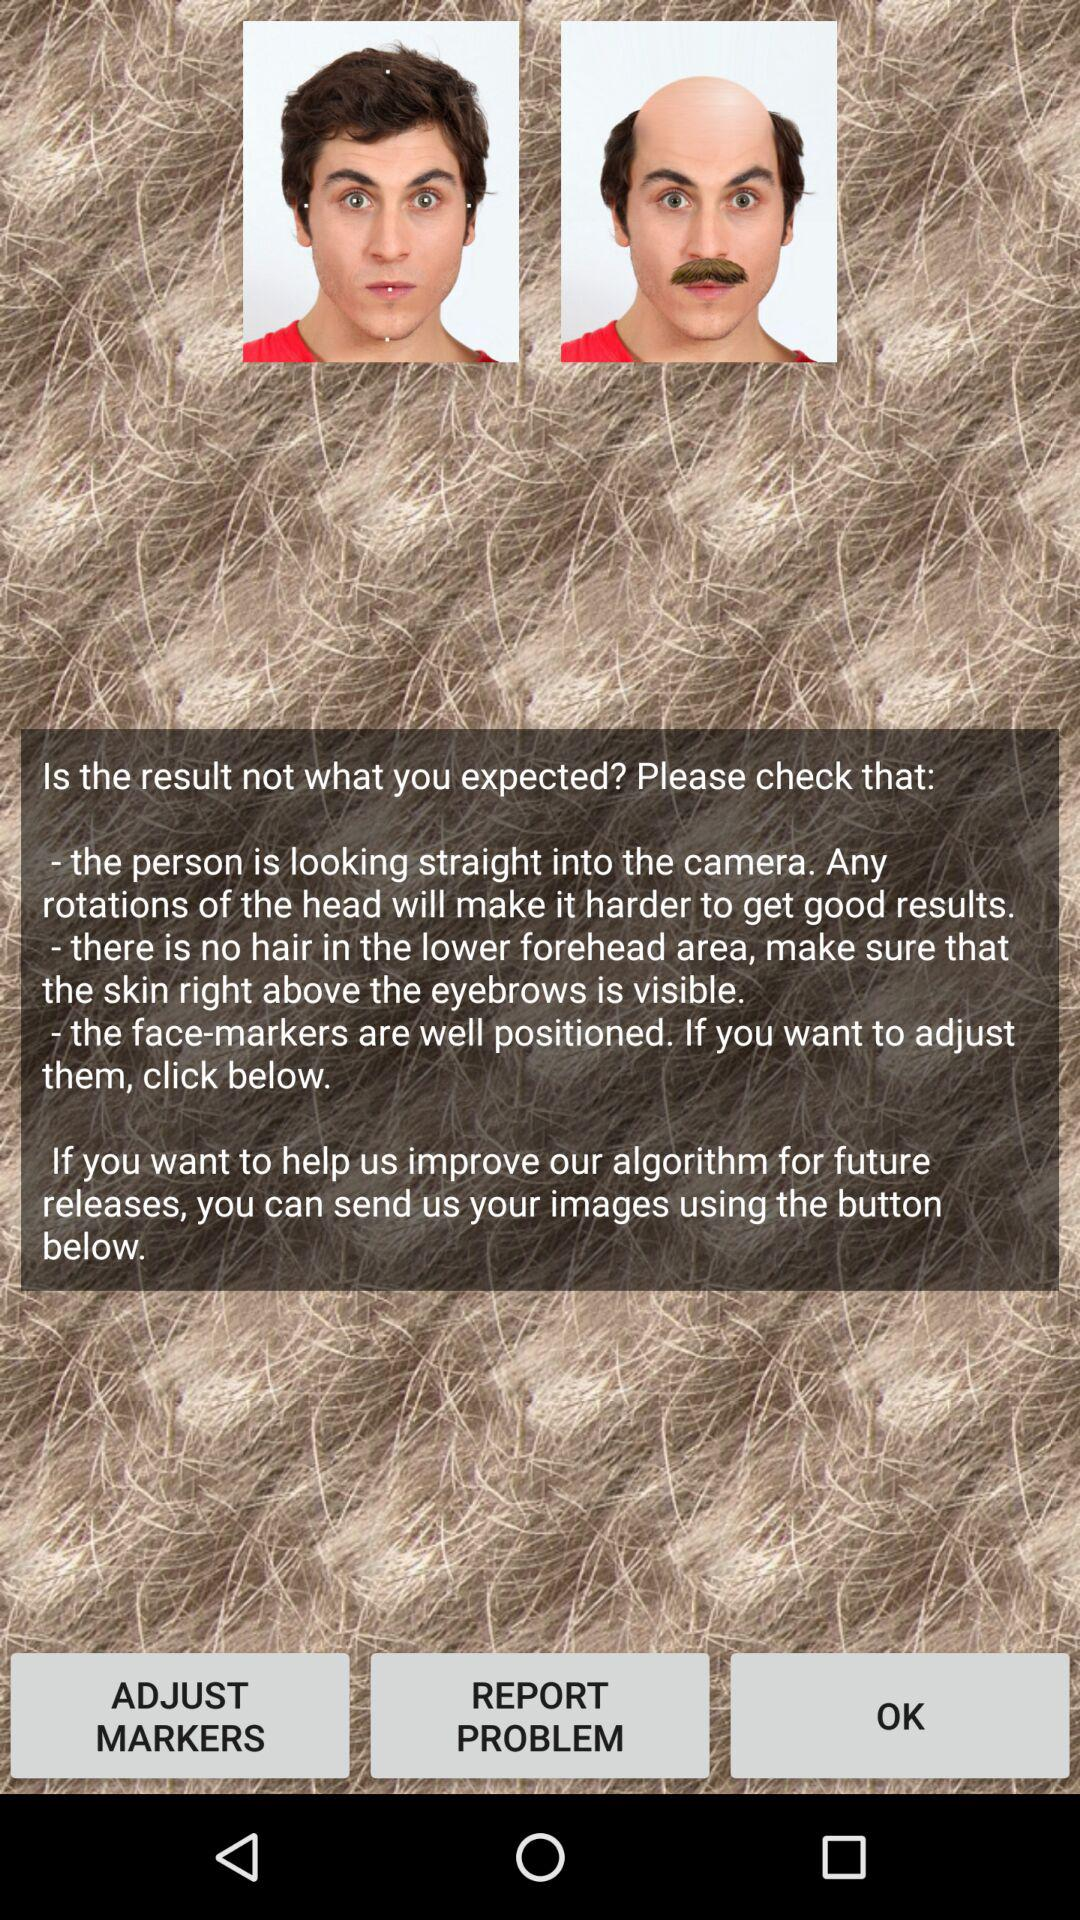What to do to make sure of good results? To make sure of good results, look straight into the camera. 